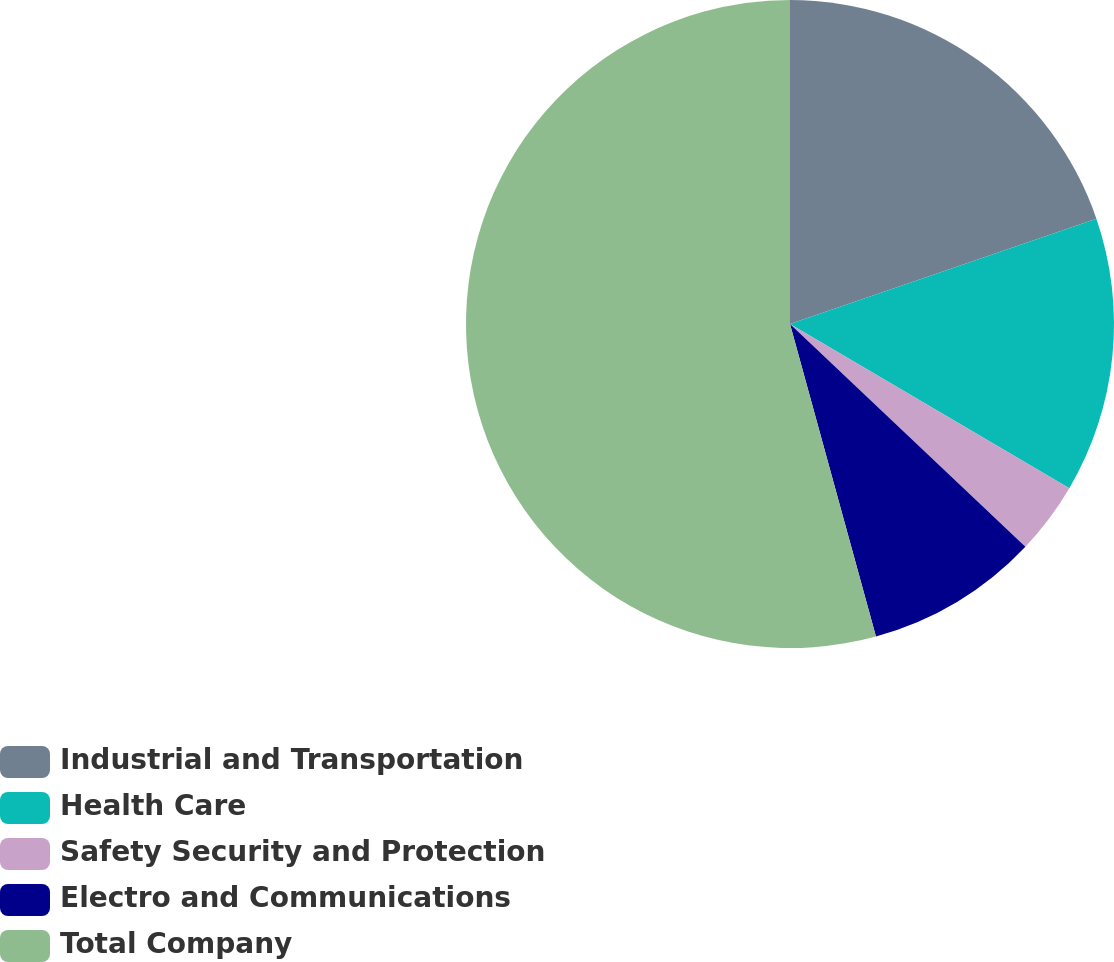Convert chart. <chart><loc_0><loc_0><loc_500><loc_500><pie_chart><fcel>Industrial and Transportation<fcel>Health Care<fcel>Safety Security and Protection<fcel>Electro and Communications<fcel>Total Company<nl><fcel>19.73%<fcel>13.73%<fcel>3.6%<fcel>8.67%<fcel>54.28%<nl></chart> 